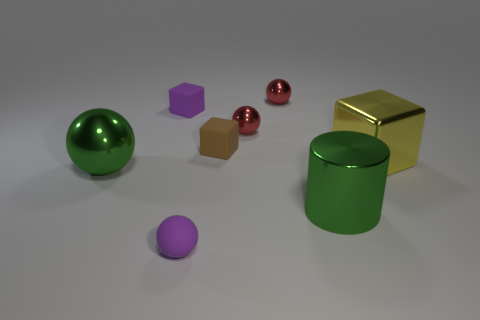Is there another small thing of the same shape as the brown thing?
Offer a terse response. Yes. How big is the block on the left side of the tiny matte sphere?
Keep it short and to the point. Small. What is the material of the purple ball that is the same size as the brown rubber cube?
Provide a short and direct response. Rubber. Is the number of brown rubber cubes greater than the number of big purple metal things?
Your answer should be compact. Yes. There is a metal cylinder that is on the right side of the big metal thing that is on the left side of the cylinder; what size is it?
Make the answer very short. Large. There is a purple thing that is the same size as the purple rubber sphere; what is its shape?
Your response must be concise. Cube. The big green thing that is to the left of the metallic object that is behind the small purple matte thing left of the tiny purple rubber ball is what shape?
Your response must be concise. Sphere. There is a small matte cube to the left of the small brown block; is its color the same as the rubber object in front of the large yellow block?
Provide a short and direct response. Yes. How many small shiny balls are there?
Make the answer very short. 2. Are there any yellow cubes right of the purple cube?
Give a very brief answer. Yes. 